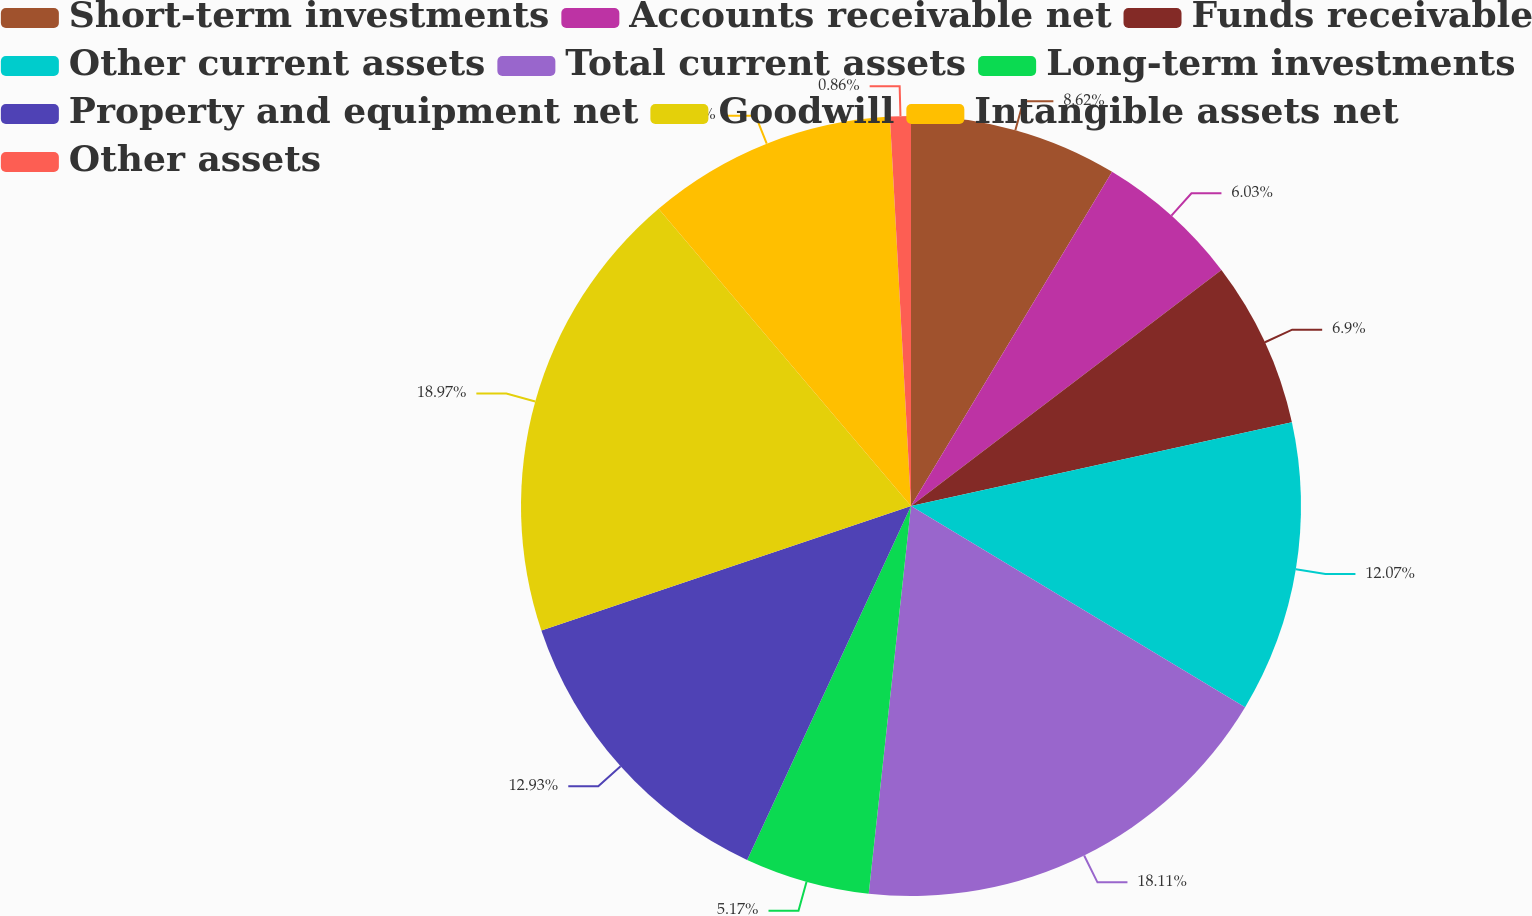<chart> <loc_0><loc_0><loc_500><loc_500><pie_chart><fcel>Short-term investments<fcel>Accounts receivable net<fcel>Funds receivable<fcel>Other current assets<fcel>Total current assets<fcel>Long-term investments<fcel>Property and equipment net<fcel>Goodwill<fcel>Intangible assets net<fcel>Other assets<nl><fcel>8.62%<fcel>6.03%<fcel>6.9%<fcel>12.07%<fcel>18.1%<fcel>5.17%<fcel>12.93%<fcel>18.96%<fcel>10.34%<fcel>0.86%<nl></chart> 